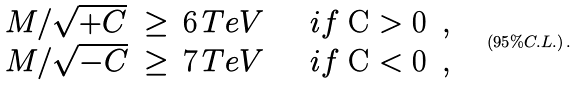<formula> <loc_0><loc_0><loc_500><loc_500>\begin{array} { l l l } M / \sqrt { + C } & \geq \, 6 \, T e V \quad & i f $ C > 0 $ \, , \\ M / \sqrt { - C } & \geq \, 7 \, T e V \quad & i f $ C < 0 $ \, , \end{array} \quad ( 9 5 \% C . L . ) \, .</formula> 